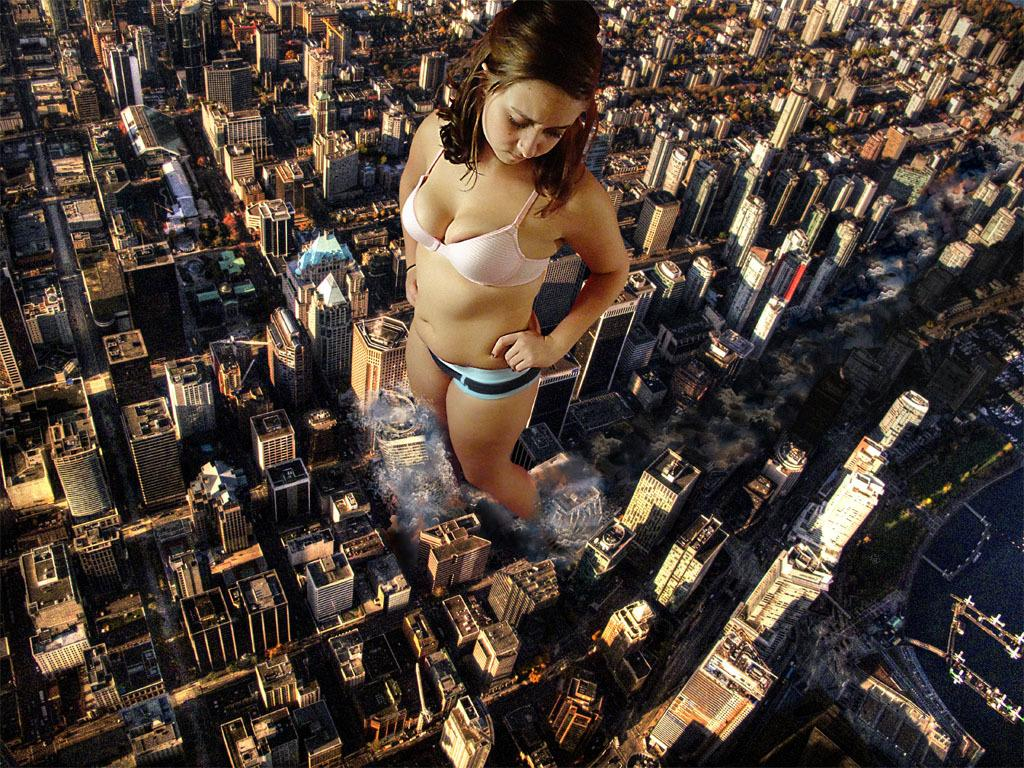Who is the main subject in the image? There is a woman standing in the center of the image. What type of structures can be seen in the background? There are buildings and houses in the image. Is there any path or route visible in the image? Yes, there is a walkway in the image. What type of produce is being carried by the donkey in the image? There is no donkey present in the image, so it is not possible to answer that question. 